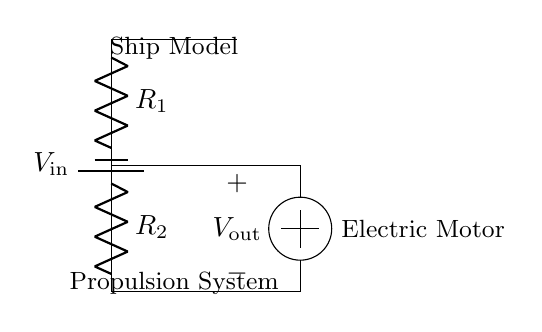What is the input voltage of the circuit? The input voltage is represented as V in the circuit diagram, which is the source that powers the voltage divider.
Answer: V in What are the two resistors in the circuit? The circuit contains two resistors labeled as R1 and R2. They are in series, which is a defining feature of a voltage divider circuit.
Answer: R1 and R2 What is the output voltage connected to? The output voltage V out is connected to the electric motor, which indicates that the motor's speed can be controlled by this output.
Answer: Electric motor How does the voltage divider affect the output voltage? The voltage divider reduces the input voltage to a smaller output voltage based on the ratio of the resistors R1 and R2, which is fundamental for controlling the motor's speed.
Answer: Reduces voltage What is the role of the resistors in controlling motor speed? The resistors R1 and R2 create a voltage division, allowing the circuit to control the motor's speed by varying the output voltage V out based on the resistance values.
Answer: Voltage division What happens if R1 is increased? Increasing R1 will raise the output voltage V out, thus increasing the speed of the electric motor because more voltage will be available for the motor's operation.
Answer: Speed increases 